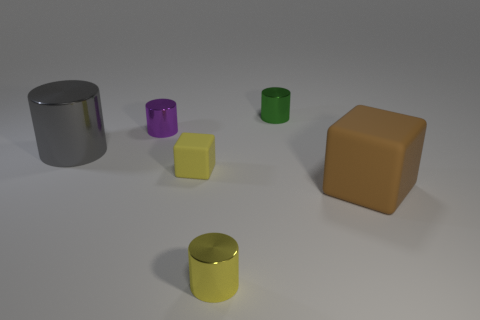There is a block that is in front of the small yellow cube; does it have the same size as the rubber thing that is to the left of the green cylinder? no 